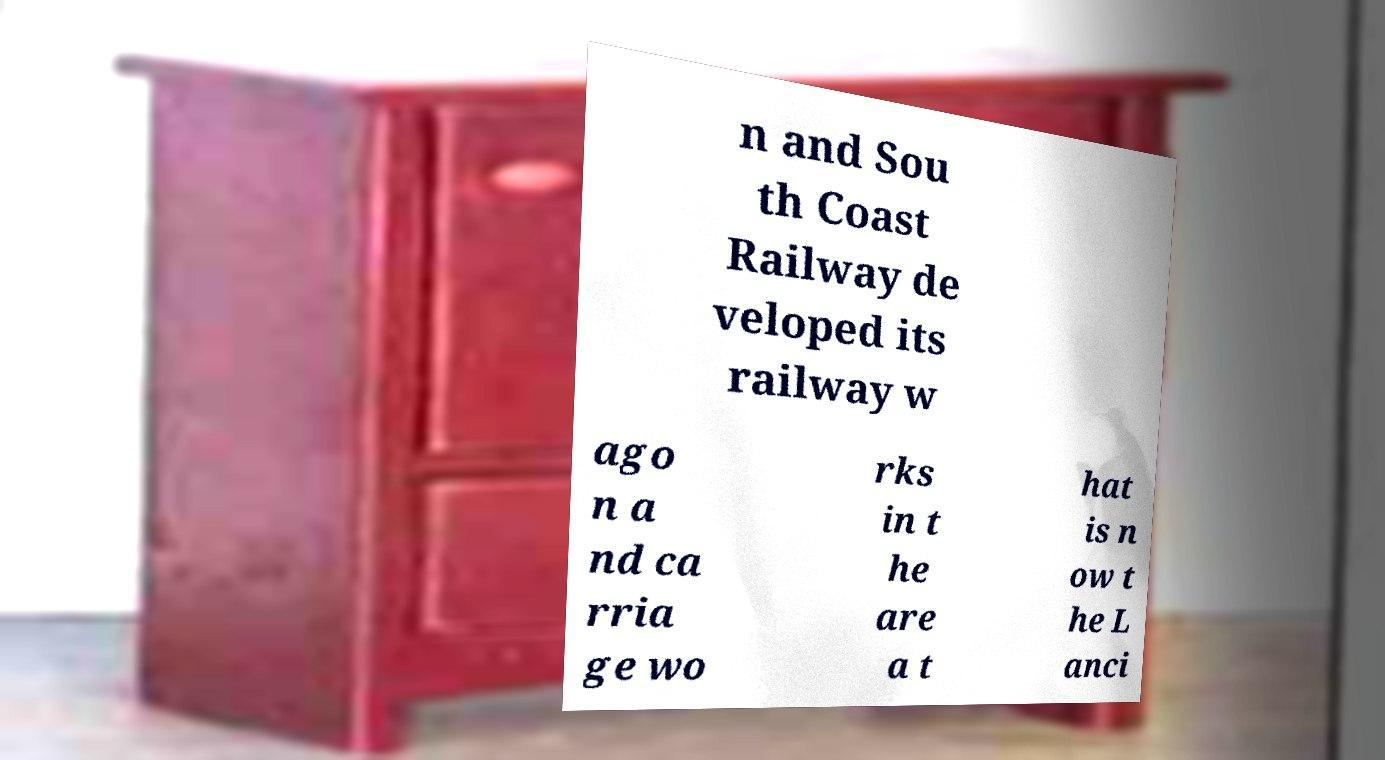I need the written content from this picture converted into text. Can you do that? n and Sou th Coast Railway de veloped its railway w ago n a nd ca rria ge wo rks in t he are a t hat is n ow t he L anci 